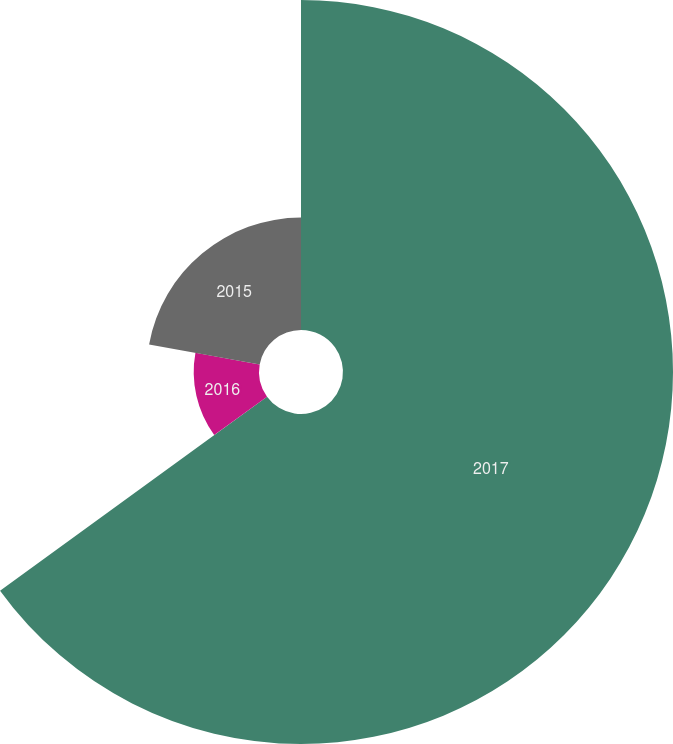<chart> <loc_0><loc_0><loc_500><loc_500><pie_chart><fcel>2017<fcel>2016<fcel>2015<nl><fcel>65.0%<fcel>12.86%<fcel>22.14%<nl></chart> 